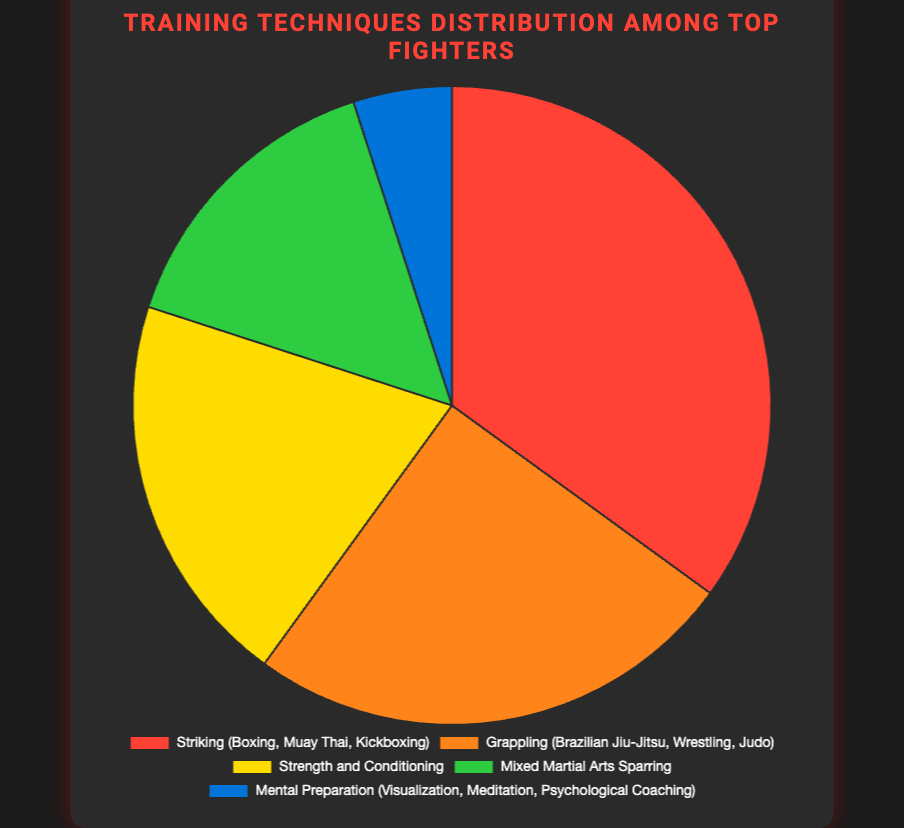Which training technique is most frequently used among top fighters? The chart shows the distribution of various training techniques. The largest segment of the pie chart represents Striking (Boxing, Muay Thai, Kickboxing) at 35%.
Answer: Striking (Boxing, Muay Thai, Kickboxing) How much more is the proportion of Striking compared to Mixed Martial Arts Sparring? Striking's proportion is 35%, and Mixed Martial Arts Sparring's proportion is 15%. The difference is 35% - 15%.
Answer: 20% Which training technique has the smallest proportion among top fighters? The smallest segment of the pie chart represents Mental Preparation (Visualization, Meditation, Psychological Coaching) at 5%.
Answer: Mental Preparation (Visualization, Meditation, Psychological Coaching) How do the combined proportions of Grappling and Strength and Conditioning compare with that of Striking? Grappling is 25%, and Strength and Conditioning is 20%, adding up to 25% + 20% = 45%. Striking is 35%. 45% is greater than 35%.
Answer: Combined Grappling and Strength and Conditioning is greater What is the total proportion of techniques focused on physical conditioning? Striking (35%), Grappling (25%), and Strength and Conditioning (20%) all contribute to physical conditioning. The total is 35% + 25% + 20%.
Answer: 80% Which segment is represented by the green color? The green segment in the pie chart corresponds to the label Mixed Martial Arts Sparring at 15%.
Answer: Mixed Martial Arts Sparring What is the proportion of non-physical preparation techniques? Only Mental Preparation (Visualization, Meditation, Psychological Coaching) is categorized as non-physical, representing 5% of the total.
Answer: 5% If you combine Strength and Conditioning with Mixed Martial Arts Sparring, how does the combined percentage compare to Grappling? Strength and Conditioning is 20%, and Mixed Martial Arts Sparring is 15%, summing up to 35%. Grappling is 25%. 35% is greater than 25%.
Answer: Combined is greater How many training techniques have a proportion equal to or greater than 20%? Striking (35%), Grappling (25%), and Strength and Conditioning (20%) each have a proportion of 20% or higher. There are three such techniques.
Answer: 3 